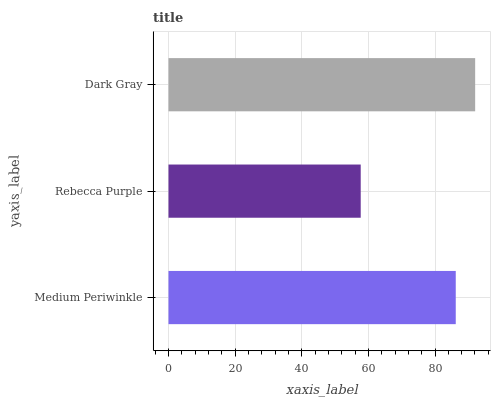Is Rebecca Purple the minimum?
Answer yes or no. Yes. Is Dark Gray the maximum?
Answer yes or no. Yes. Is Dark Gray the minimum?
Answer yes or no. No. Is Rebecca Purple the maximum?
Answer yes or no. No. Is Dark Gray greater than Rebecca Purple?
Answer yes or no. Yes. Is Rebecca Purple less than Dark Gray?
Answer yes or no. Yes. Is Rebecca Purple greater than Dark Gray?
Answer yes or no. No. Is Dark Gray less than Rebecca Purple?
Answer yes or no. No. Is Medium Periwinkle the high median?
Answer yes or no. Yes. Is Medium Periwinkle the low median?
Answer yes or no. Yes. Is Rebecca Purple the high median?
Answer yes or no. No. Is Dark Gray the low median?
Answer yes or no. No. 